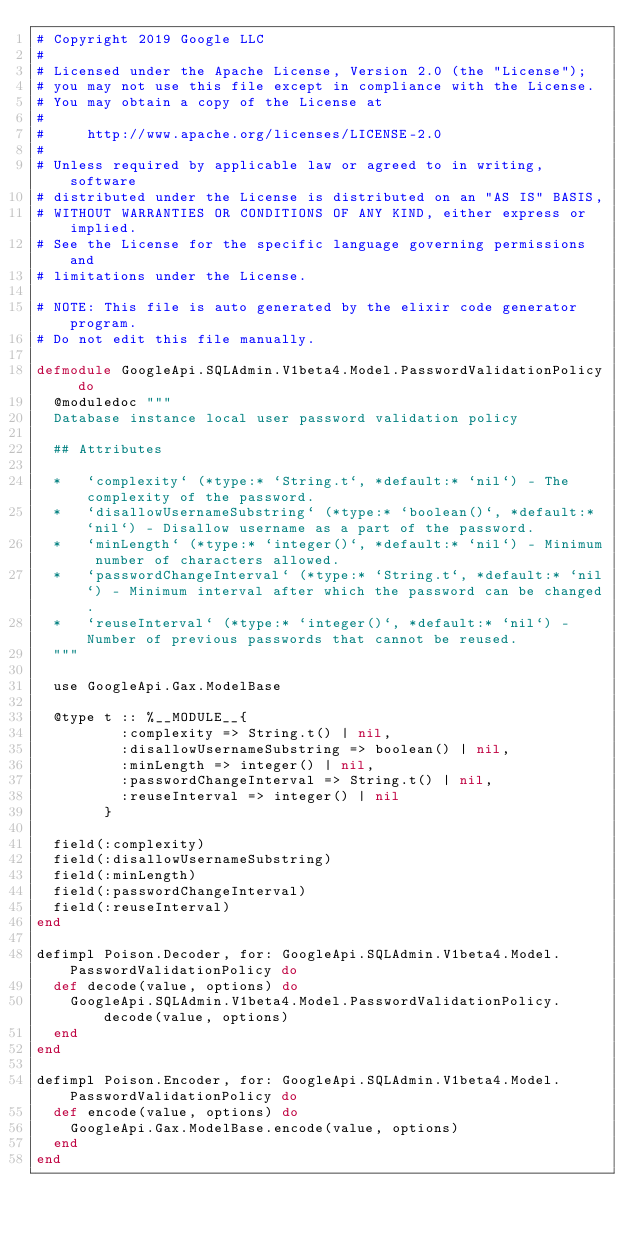<code> <loc_0><loc_0><loc_500><loc_500><_Elixir_># Copyright 2019 Google LLC
#
# Licensed under the Apache License, Version 2.0 (the "License");
# you may not use this file except in compliance with the License.
# You may obtain a copy of the License at
#
#     http://www.apache.org/licenses/LICENSE-2.0
#
# Unless required by applicable law or agreed to in writing, software
# distributed under the License is distributed on an "AS IS" BASIS,
# WITHOUT WARRANTIES OR CONDITIONS OF ANY KIND, either express or implied.
# See the License for the specific language governing permissions and
# limitations under the License.

# NOTE: This file is auto generated by the elixir code generator program.
# Do not edit this file manually.

defmodule GoogleApi.SQLAdmin.V1beta4.Model.PasswordValidationPolicy do
  @moduledoc """
  Database instance local user password validation policy

  ## Attributes

  *   `complexity` (*type:* `String.t`, *default:* `nil`) - The complexity of the password.
  *   `disallowUsernameSubstring` (*type:* `boolean()`, *default:* `nil`) - Disallow username as a part of the password.
  *   `minLength` (*type:* `integer()`, *default:* `nil`) - Minimum number of characters allowed.
  *   `passwordChangeInterval` (*type:* `String.t`, *default:* `nil`) - Minimum interval after which the password can be changed.
  *   `reuseInterval` (*type:* `integer()`, *default:* `nil`) - Number of previous passwords that cannot be reused.
  """

  use GoogleApi.Gax.ModelBase

  @type t :: %__MODULE__{
          :complexity => String.t() | nil,
          :disallowUsernameSubstring => boolean() | nil,
          :minLength => integer() | nil,
          :passwordChangeInterval => String.t() | nil,
          :reuseInterval => integer() | nil
        }

  field(:complexity)
  field(:disallowUsernameSubstring)
  field(:minLength)
  field(:passwordChangeInterval)
  field(:reuseInterval)
end

defimpl Poison.Decoder, for: GoogleApi.SQLAdmin.V1beta4.Model.PasswordValidationPolicy do
  def decode(value, options) do
    GoogleApi.SQLAdmin.V1beta4.Model.PasswordValidationPolicy.decode(value, options)
  end
end

defimpl Poison.Encoder, for: GoogleApi.SQLAdmin.V1beta4.Model.PasswordValidationPolicy do
  def encode(value, options) do
    GoogleApi.Gax.ModelBase.encode(value, options)
  end
end
</code> 